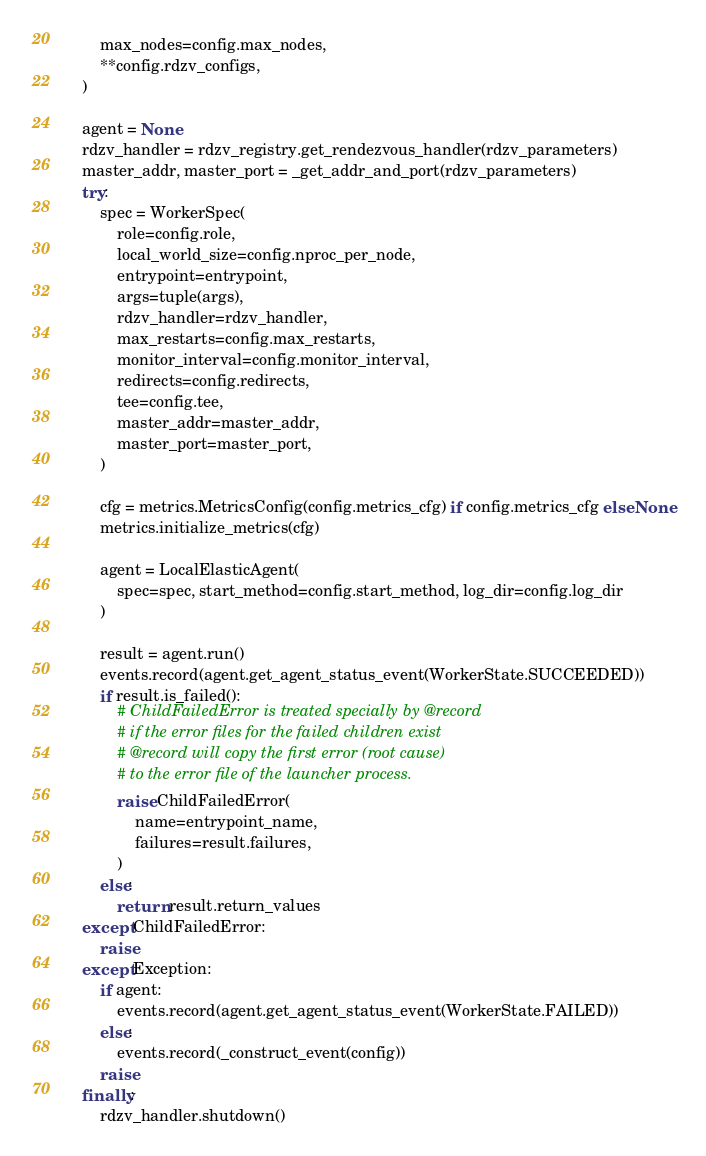<code> <loc_0><loc_0><loc_500><loc_500><_Python_>        max_nodes=config.max_nodes,
        **config.rdzv_configs,
    )

    agent = None
    rdzv_handler = rdzv_registry.get_rendezvous_handler(rdzv_parameters)
    master_addr, master_port = _get_addr_and_port(rdzv_parameters)
    try:
        spec = WorkerSpec(
            role=config.role,
            local_world_size=config.nproc_per_node,
            entrypoint=entrypoint,
            args=tuple(args),
            rdzv_handler=rdzv_handler,
            max_restarts=config.max_restarts,
            monitor_interval=config.monitor_interval,
            redirects=config.redirects,
            tee=config.tee,
            master_addr=master_addr,
            master_port=master_port,
        )

        cfg = metrics.MetricsConfig(config.metrics_cfg) if config.metrics_cfg else None
        metrics.initialize_metrics(cfg)

        agent = LocalElasticAgent(
            spec=spec, start_method=config.start_method, log_dir=config.log_dir
        )

        result = agent.run()
        events.record(agent.get_agent_status_event(WorkerState.SUCCEEDED))
        if result.is_failed():
            # ChildFailedError is treated specially by @record
            # if the error files for the failed children exist
            # @record will copy the first error (root cause)
            # to the error file of the launcher process.
            raise ChildFailedError(
                name=entrypoint_name,
                failures=result.failures,
            )
        else:
            return result.return_values
    except ChildFailedError:
        raise
    except Exception:
        if agent:
            events.record(agent.get_agent_status_event(WorkerState.FAILED))
        else:
            events.record(_construct_event(config))
        raise
    finally:
        rdzv_handler.shutdown()
</code> 